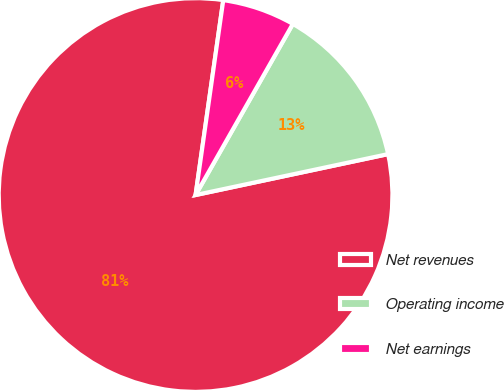<chart> <loc_0><loc_0><loc_500><loc_500><pie_chart><fcel>Net revenues<fcel>Operating income<fcel>Net earnings<nl><fcel>80.58%<fcel>13.44%<fcel>5.98%<nl></chart> 